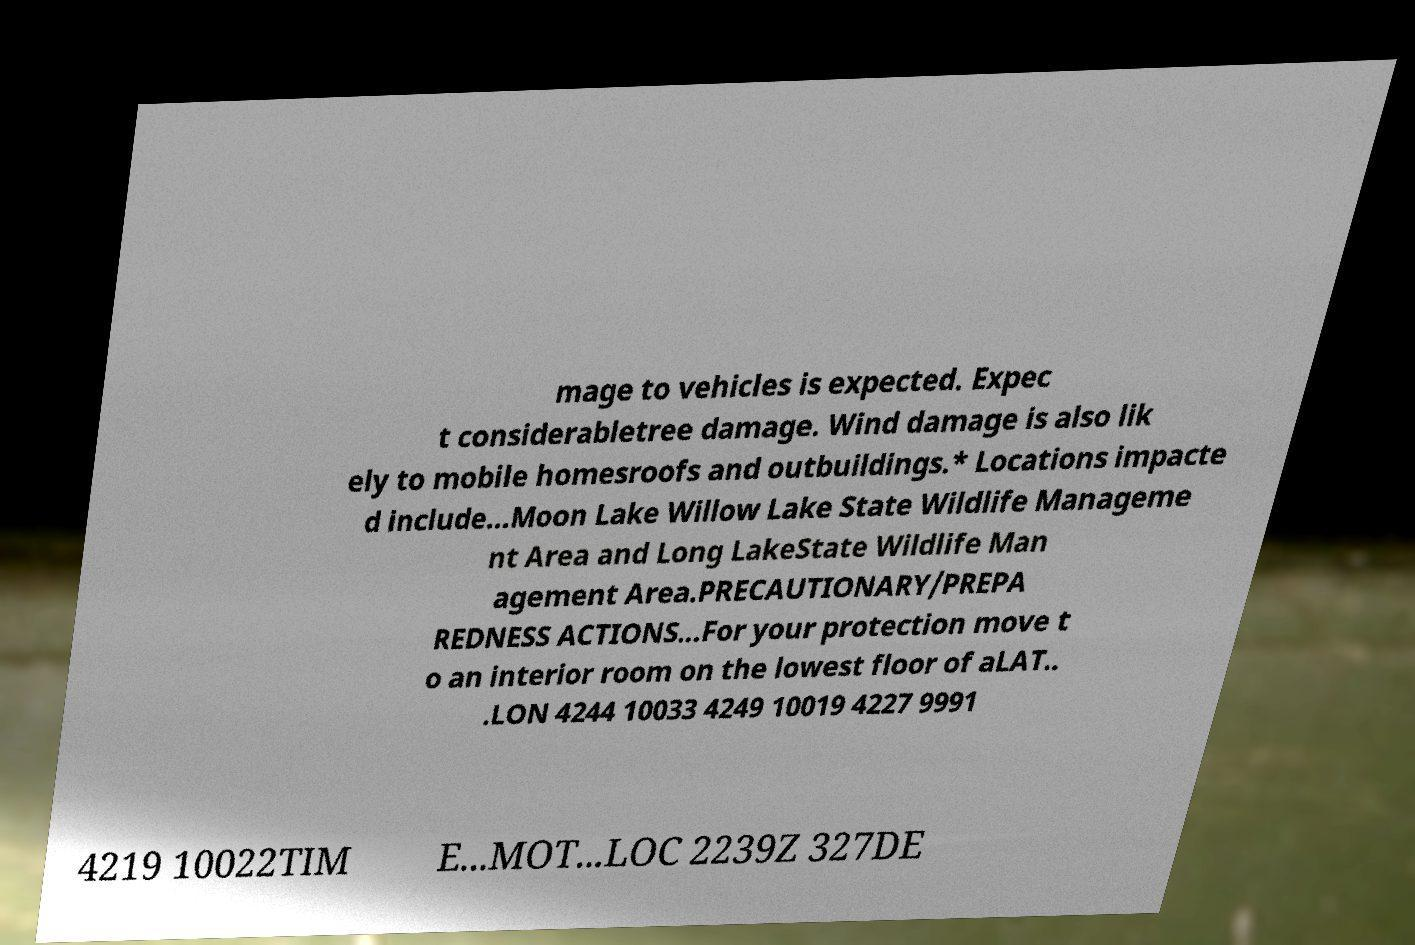I need the written content from this picture converted into text. Can you do that? mage to vehicles is expected. Expec t considerabletree damage. Wind damage is also lik ely to mobile homesroofs and outbuildings.* Locations impacte d include...Moon Lake Willow Lake State Wildlife Manageme nt Area and Long LakeState Wildlife Man agement Area.PRECAUTIONARY/PREPA REDNESS ACTIONS...For your protection move t o an interior room on the lowest floor of aLAT.. .LON 4244 10033 4249 10019 4227 9991 4219 10022TIM E...MOT...LOC 2239Z 327DE 